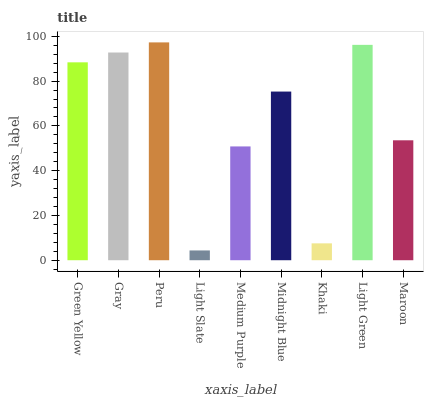Is Light Slate the minimum?
Answer yes or no. Yes. Is Peru the maximum?
Answer yes or no. Yes. Is Gray the minimum?
Answer yes or no. No. Is Gray the maximum?
Answer yes or no. No. Is Gray greater than Green Yellow?
Answer yes or no. Yes. Is Green Yellow less than Gray?
Answer yes or no. Yes. Is Green Yellow greater than Gray?
Answer yes or no. No. Is Gray less than Green Yellow?
Answer yes or no. No. Is Midnight Blue the high median?
Answer yes or no. Yes. Is Midnight Blue the low median?
Answer yes or no. Yes. Is Green Yellow the high median?
Answer yes or no. No. Is Light Slate the low median?
Answer yes or no. No. 